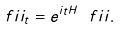Convert formula to latex. <formula><loc_0><loc_0><loc_500><loc_500>\ f i i _ { t } = e ^ { i t H } \ f i i .</formula> 